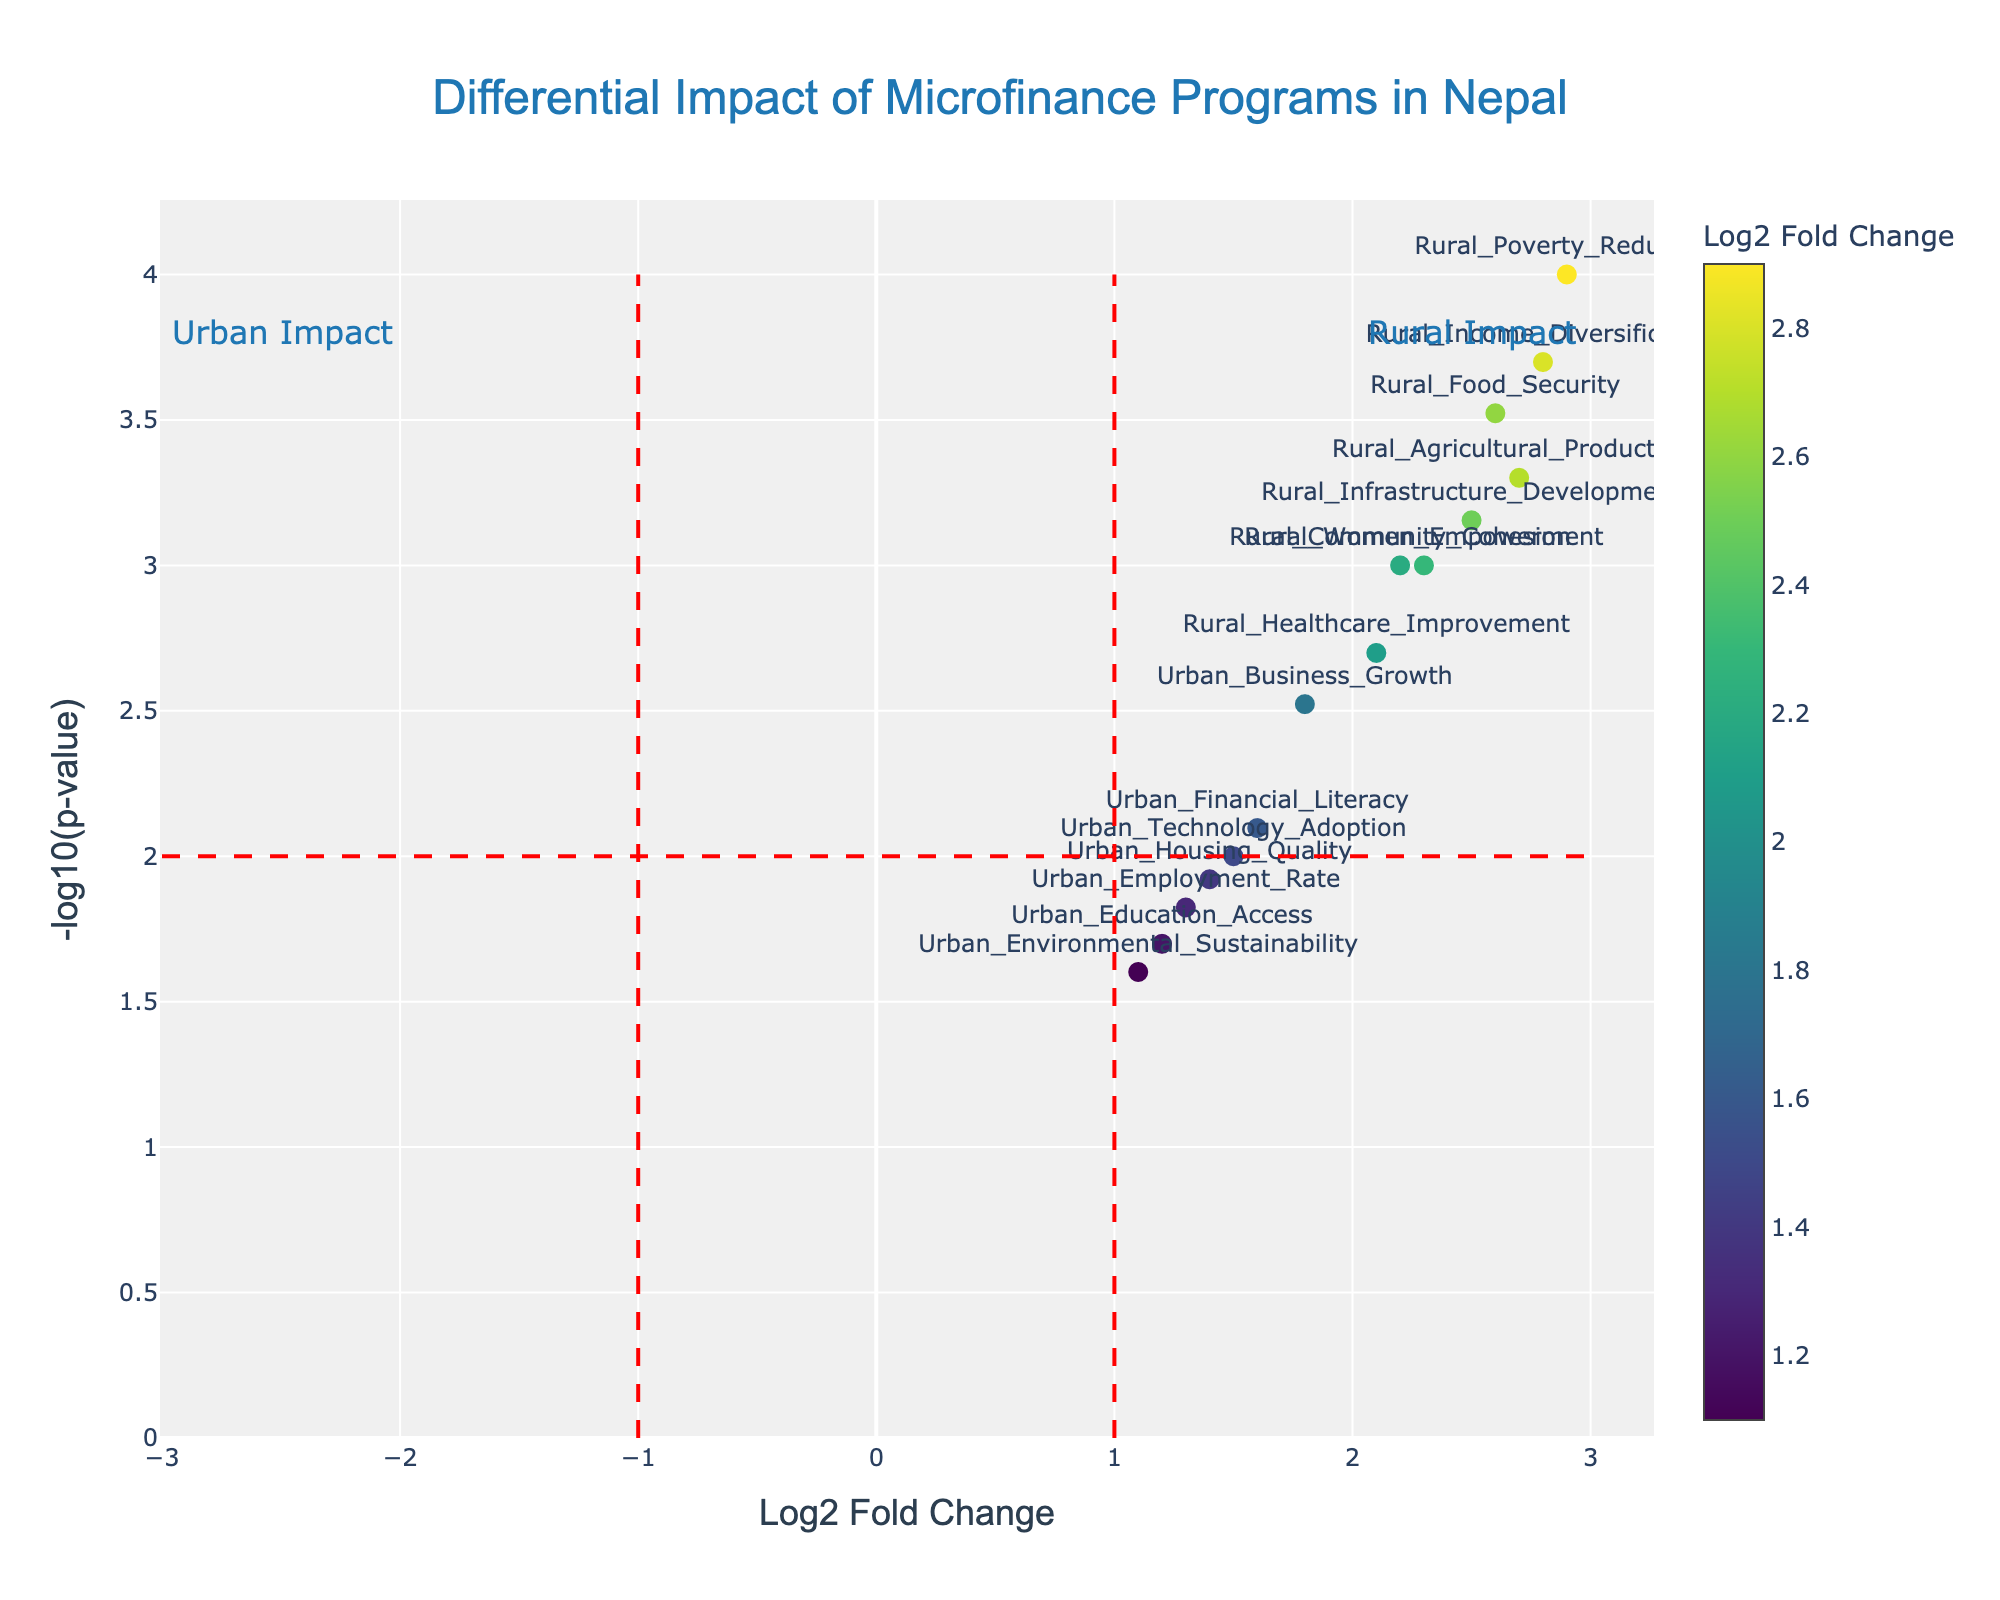What does the title of the plot indicate? The title of the plot is "Differential Impact of Microfinance Programs in Nepal," which indicates that the plot represents how microfinance programs affect different aspects of rural and urban communities in Nepal.
Answer: Differential Impact of Microfinance Programs in Nepal How are the x-axis and y-axis labeled? The x-axis is labeled "Log2 Fold Change," and the y-axis is labeled "-log10(p-value)." These labels help in understanding the significance and magnitude of the changes observed.
Answer: Log2 Fold Change and -log10(p-value) How many rural data points are shown in the plot? By counting the labels associated with rural impacts in the plot, we find that there are eight data points related to rural impacts.
Answer: Eight Which data point has the highest Log2 Fold Change value? Rural_Poverty_Reduction has the highest Log2 Fold Change value of 2.9, indicating a significant impact on reducing poverty in rural areas.
Answer: Rural_Poverty_Reduction Which data point has the lowest p-value? Rural_Poverty_Reduction has the lowest p-value of 0.0001, making it the most statistically significant result in the plot.
Answer: Rural_Poverty_Reduction What is the general trend observed between rural and urban impacts based on the figure? The general trend shows that rural impacts generally have higher Log2 Fold Changes and lower p-values compared to urban impacts, suggesting a stronger and more significant effect of microfinance programs in rural areas.
Answer: Rural impacts are stronger and more significant Compare the statistical significance (p-values) of Rural_Agricultural_Productivity and Urban_Business_Growth. Which is more significant? Rural_Agricultural_Productivity has a p-value of 0.0005, whereas Urban_Business_Growth has a p-value of 0.003. Lower p-values indicate higher statistical significance.
Answer: Rural_Agricultural_Productivity is more significant Why might there be vertical and horizontal red dash lines in a volcano plot? The vertical red dash lines at Log2 Fold Change of -1 and +1 and the horizontal red dash line at -log10(p-value) of 2 are thresholds to indicate statistically significant changes and thresholds for fold change. Points outside these thresholds are often considered significant.
Answer: To indicate significant thresholds Identify an urban impact with a Log2 Fold Change close to the fold change threshold. Urban_Technology_Adoption has a Log2 Fold Change of 1.5, which is close to the fold change threshold of 1.
Answer: Urban_Technology_Adoption 